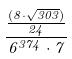Convert formula to latex. <formula><loc_0><loc_0><loc_500><loc_500>\frac { \frac { ( 8 \cdot \sqrt { 3 0 3 } ) } { 2 4 } } { 6 ^ { 3 7 4 } \cdot 7 }</formula> 